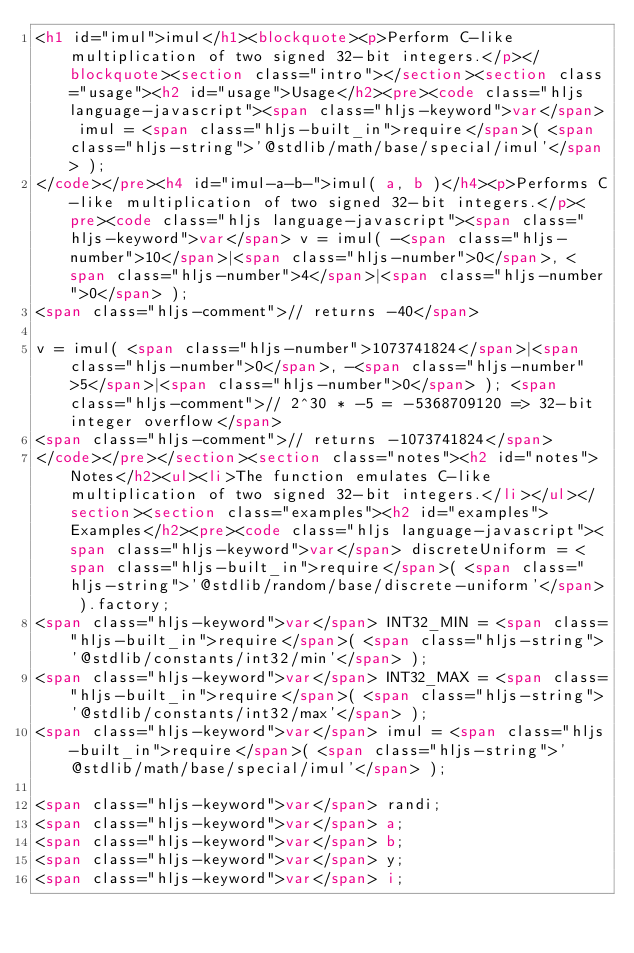<code> <loc_0><loc_0><loc_500><loc_500><_HTML_><h1 id="imul">imul</h1><blockquote><p>Perform C-like multiplication of two signed 32-bit integers.</p></blockquote><section class="intro"></section><section class="usage"><h2 id="usage">Usage</h2><pre><code class="hljs language-javascript"><span class="hljs-keyword">var</span> imul = <span class="hljs-built_in">require</span>( <span class="hljs-string">'@stdlib/math/base/special/imul'</span> );
</code></pre><h4 id="imul-a-b-">imul( a, b )</h4><p>Performs C-like multiplication of two signed 32-bit integers.</p><pre><code class="hljs language-javascript"><span class="hljs-keyword">var</span> v = imul( -<span class="hljs-number">10</span>|<span class="hljs-number">0</span>, <span class="hljs-number">4</span>|<span class="hljs-number">0</span> );
<span class="hljs-comment">// returns -40</span>

v = imul( <span class="hljs-number">1073741824</span>|<span class="hljs-number">0</span>, -<span class="hljs-number">5</span>|<span class="hljs-number">0</span> ); <span class="hljs-comment">// 2^30 * -5 = -5368709120 => 32-bit integer overflow</span>
<span class="hljs-comment">// returns -1073741824</span>
</code></pre></section><section class="notes"><h2 id="notes">Notes</h2><ul><li>The function emulates C-like multiplication of two signed 32-bit integers.</li></ul></section><section class="examples"><h2 id="examples">Examples</h2><pre><code class="hljs language-javascript"><span class="hljs-keyword">var</span> discreteUniform = <span class="hljs-built_in">require</span>( <span class="hljs-string">'@stdlib/random/base/discrete-uniform'</span> ).factory;
<span class="hljs-keyword">var</span> INT32_MIN = <span class="hljs-built_in">require</span>( <span class="hljs-string">'@stdlib/constants/int32/min'</span> );
<span class="hljs-keyword">var</span> INT32_MAX = <span class="hljs-built_in">require</span>( <span class="hljs-string">'@stdlib/constants/int32/max'</span> );
<span class="hljs-keyword">var</span> imul = <span class="hljs-built_in">require</span>( <span class="hljs-string">'@stdlib/math/base/special/imul'</span> );

<span class="hljs-keyword">var</span> randi;
<span class="hljs-keyword">var</span> a;
<span class="hljs-keyword">var</span> b;
<span class="hljs-keyword">var</span> y;
<span class="hljs-keyword">var</span> i;
</code> 